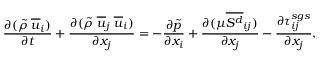<formula> <loc_0><loc_0><loc_500><loc_500>\frac { \partial ( \tilde { \rho } \, \overline { u } _ { i } ) } { \partial t } + \frac { \partial ( \tilde { \rho } \, \overline { u } _ { j } \, \overline { u } _ { i } ) } { \partial x _ { j } } = - \frac { \partial \tilde { p } } { \partial x _ { i } } + \frac { \partial ( \mu \overline { { S ^ { d } } } _ { i j } ) } { \partial x _ { j } } - \frac { \partial \tau _ { i j } ^ { s g s } } { \partial x _ { j } } ,</formula> 